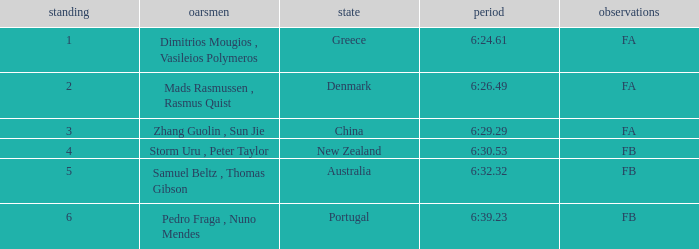What country has a rank smaller than 6, a time of 6:32.32 and notes of FB? Australia. 